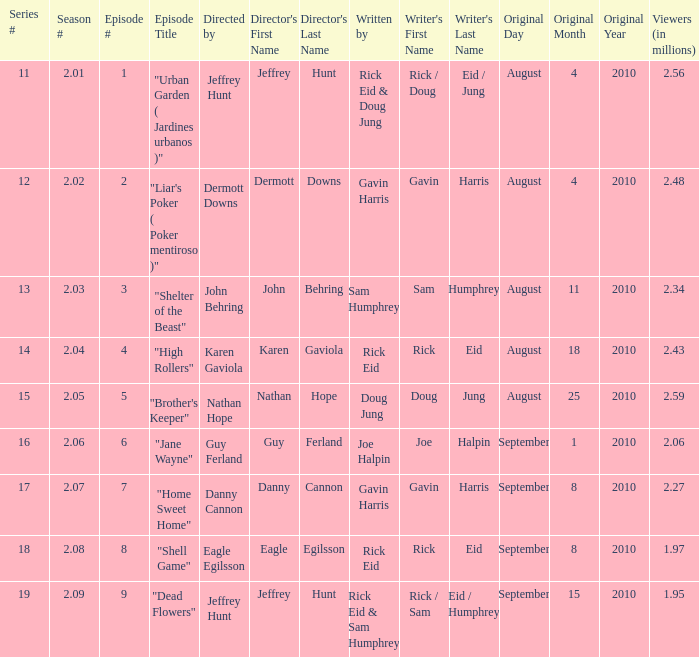What is the amount of viewers if the series number is 14? 2.43. 